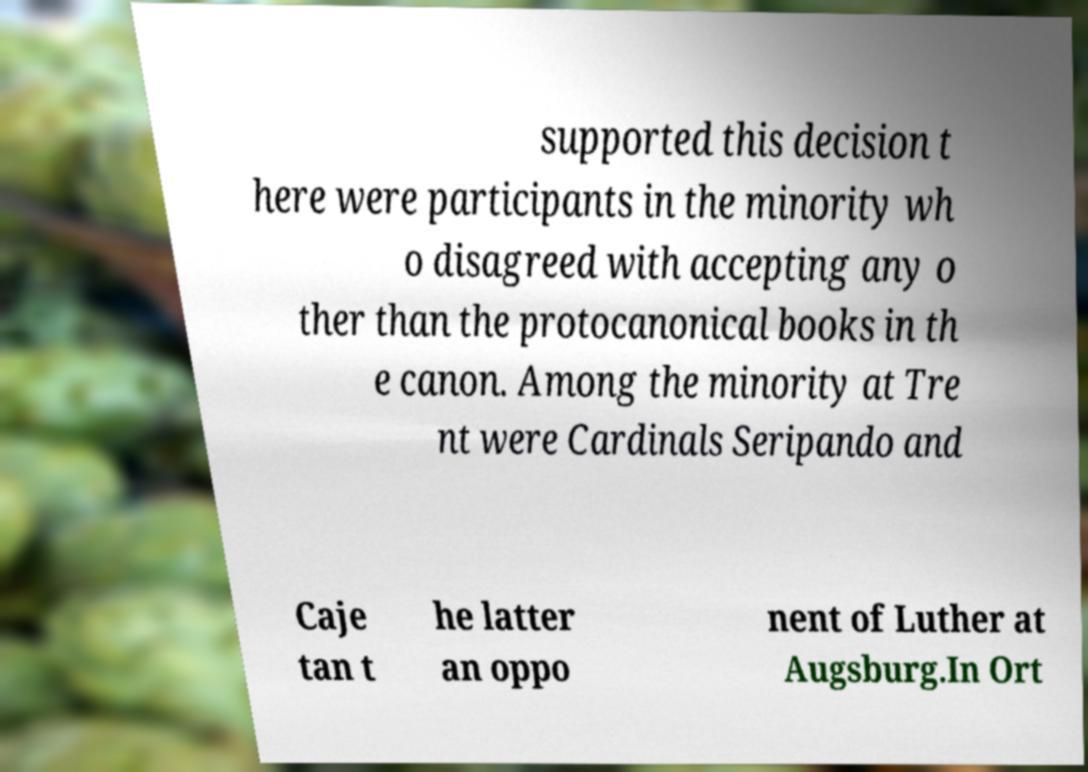For documentation purposes, I need the text within this image transcribed. Could you provide that? supported this decision t here were participants in the minority wh o disagreed with accepting any o ther than the protocanonical books in th e canon. Among the minority at Tre nt were Cardinals Seripando and Caje tan t he latter an oppo nent of Luther at Augsburg.In Ort 